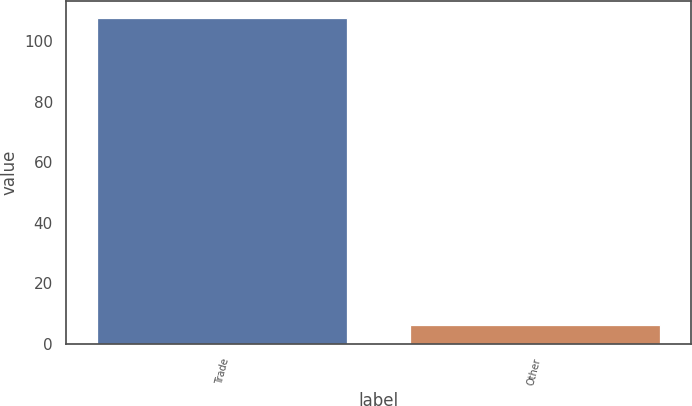<chart> <loc_0><loc_0><loc_500><loc_500><bar_chart><fcel>Trade<fcel>Other<nl><fcel>107.8<fcel>6.1<nl></chart> 